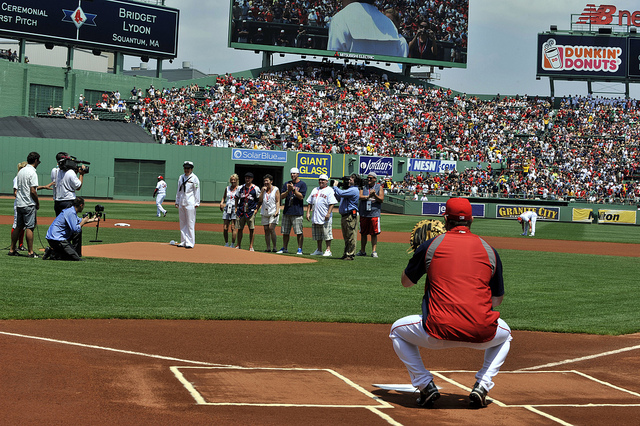<image>Which advertisement begins with the letter M? I am unsure which advertisement begins with the letter M. It could be 'mesh', 'milton', or 'mitsubishi electric'. Which advertisement begins with the letter M? I don't know which advertisement begins with the letter M. 